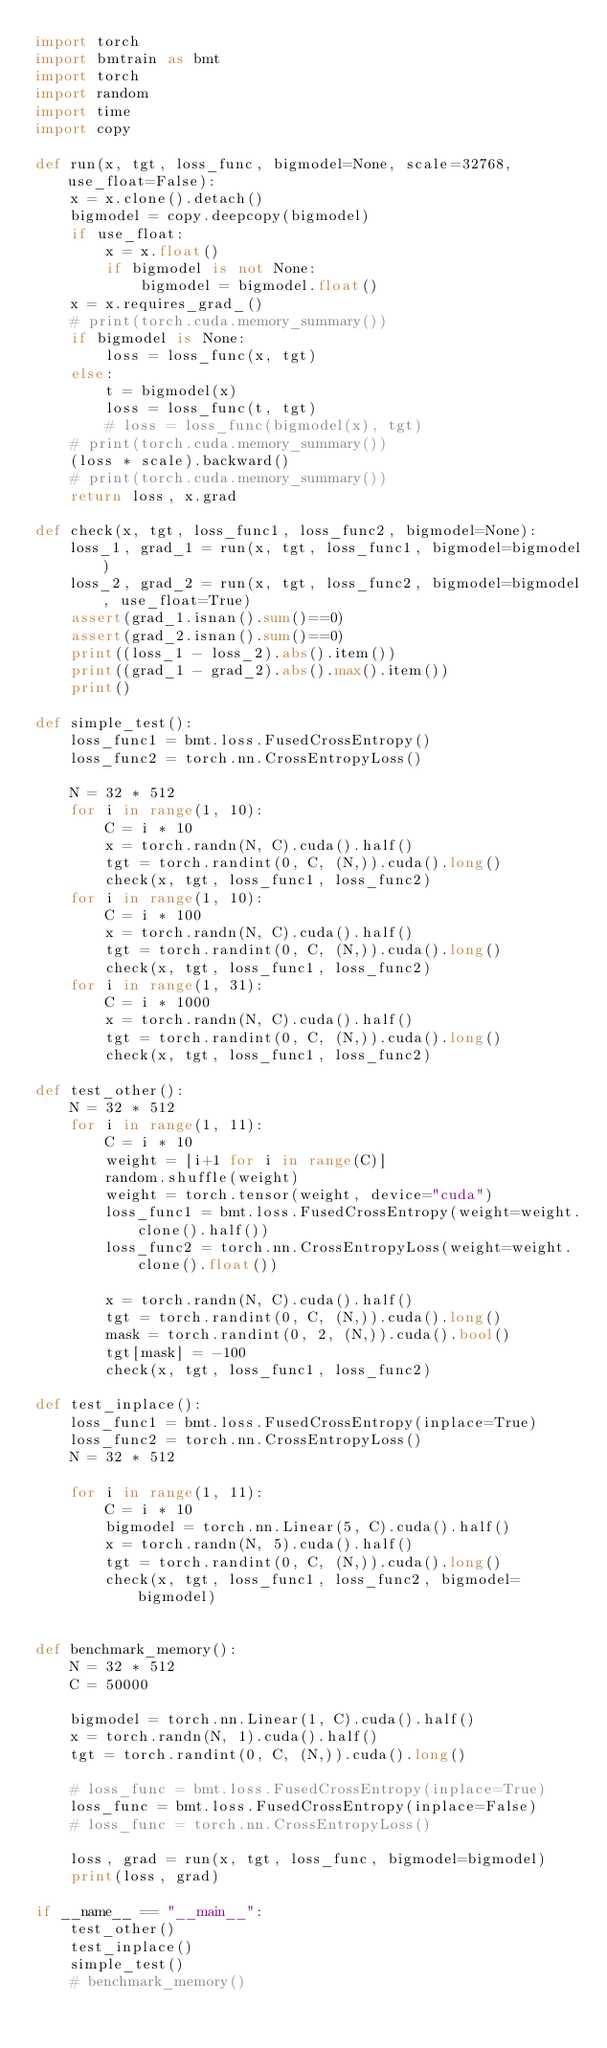<code> <loc_0><loc_0><loc_500><loc_500><_Python_>import torch
import bmtrain as bmt
import torch
import random
import time
import copy

def run(x, tgt, loss_func, bigmodel=None, scale=32768, use_float=False):
    x = x.clone().detach()
    bigmodel = copy.deepcopy(bigmodel)
    if use_float:
        x = x.float()
        if bigmodel is not None:
            bigmodel = bigmodel.float()
    x = x.requires_grad_()
    # print(torch.cuda.memory_summary())
    if bigmodel is None:
        loss = loss_func(x, tgt)
    else:
        t = bigmodel(x)
        loss = loss_func(t, tgt)
        # loss = loss_func(bigmodel(x), tgt)
    # print(torch.cuda.memory_summary())
    (loss * scale).backward()
    # print(torch.cuda.memory_summary())
    return loss, x.grad

def check(x, tgt, loss_func1, loss_func2, bigmodel=None):
    loss_1, grad_1 = run(x, tgt, loss_func1, bigmodel=bigmodel)
    loss_2, grad_2 = run(x, tgt, loss_func2, bigmodel=bigmodel, use_float=True)
    assert(grad_1.isnan().sum()==0)
    assert(grad_2.isnan().sum()==0)
    print((loss_1 - loss_2).abs().item())
    print((grad_1 - grad_2).abs().max().item())
    print()

def simple_test():
    loss_func1 = bmt.loss.FusedCrossEntropy()
    loss_func2 = torch.nn.CrossEntropyLoss()

    N = 32 * 512
    for i in range(1, 10):
        C = i * 10
        x = torch.randn(N, C).cuda().half()
        tgt = torch.randint(0, C, (N,)).cuda().long()
        check(x, tgt, loss_func1, loss_func2)
    for i in range(1, 10):
        C = i * 100
        x = torch.randn(N, C).cuda().half()
        tgt = torch.randint(0, C, (N,)).cuda().long()
        check(x, tgt, loss_func1, loss_func2)
    for i in range(1, 31):
        C = i * 1000
        x = torch.randn(N, C).cuda().half()
        tgt = torch.randint(0, C, (N,)).cuda().long()
        check(x, tgt, loss_func1, loss_func2)

def test_other():
    N = 32 * 512
    for i in range(1, 11):
        C = i * 10
        weight = [i+1 for i in range(C)]
        random.shuffle(weight)
        weight = torch.tensor(weight, device="cuda")
        loss_func1 = bmt.loss.FusedCrossEntropy(weight=weight.clone().half())
        loss_func2 = torch.nn.CrossEntropyLoss(weight=weight.clone().float())

        x = torch.randn(N, C).cuda().half()
        tgt = torch.randint(0, C, (N,)).cuda().long()
        mask = torch.randint(0, 2, (N,)).cuda().bool()
        tgt[mask] = -100
        check(x, tgt, loss_func1, loss_func2)

def test_inplace():
    loss_func1 = bmt.loss.FusedCrossEntropy(inplace=True)
    loss_func2 = torch.nn.CrossEntropyLoss()
    N = 32 * 512

    for i in range(1, 11):
        C = i * 10
        bigmodel = torch.nn.Linear(5, C).cuda().half()
        x = torch.randn(N, 5).cuda().half()
        tgt = torch.randint(0, C, (N,)).cuda().long()
        check(x, tgt, loss_func1, loss_func2, bigmodel=bigmodel)


def benchmark_memory():
    N = 32 * 512
    C = 50000

    bigmodel = torch.nn.Linear(1, C).cuda().half()
    x = torch.randn(N, 1).cuda().half()
    tgt = torch.randint(0, C, (N,)).cuda().long()

    # loss_func = bmt.loss.FusedCrossEntropy(inplace=True)
    loss_func = bmt.loss.FusedCrossEntropy(inplace=False)
    # loss_func = torch.nn.CrossEntropyLoss()

    loss, grad = run(x, tgt, loss_func, bigmodel=bigmodel)
    print(loss, grad)

if __name__ == "__main__":
    test_other()
    test_inplace()
    simple_test()
    # benchmark_memory()</code> 